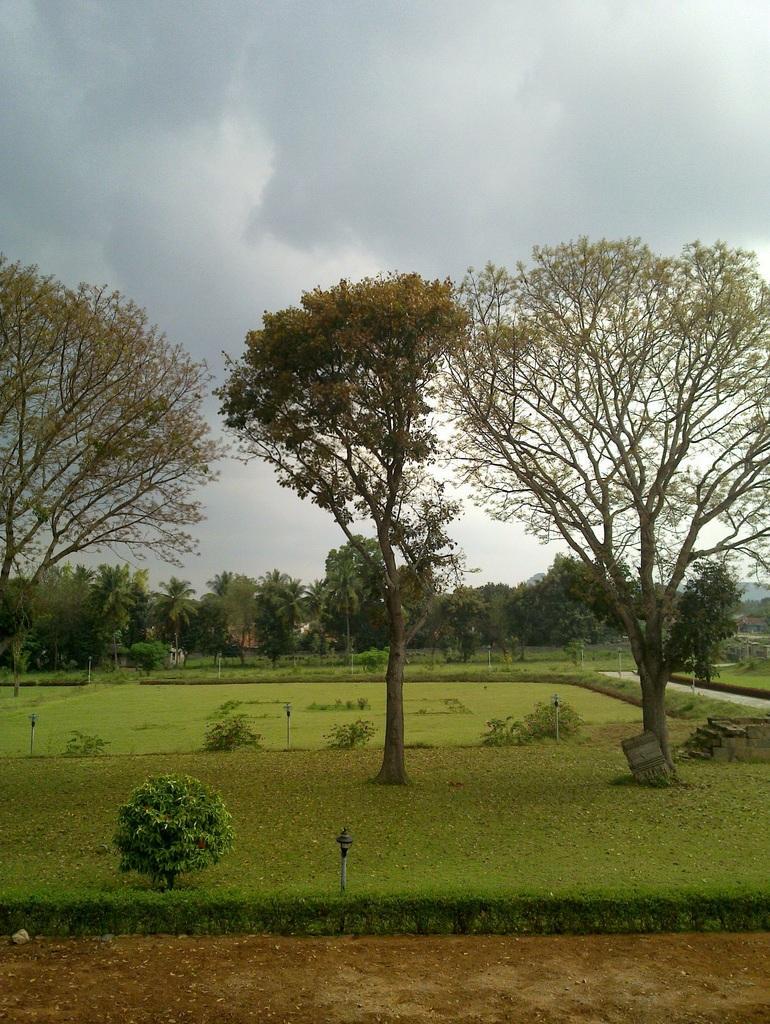In one or two sentences, can you explain what this image depicts? In the picture we can see a path beside it, we can see a grass surface on it, we can see a lamp with some plant beside it and in the background, we can see some trees and far from it also we can see many trees and sky with clouds. 